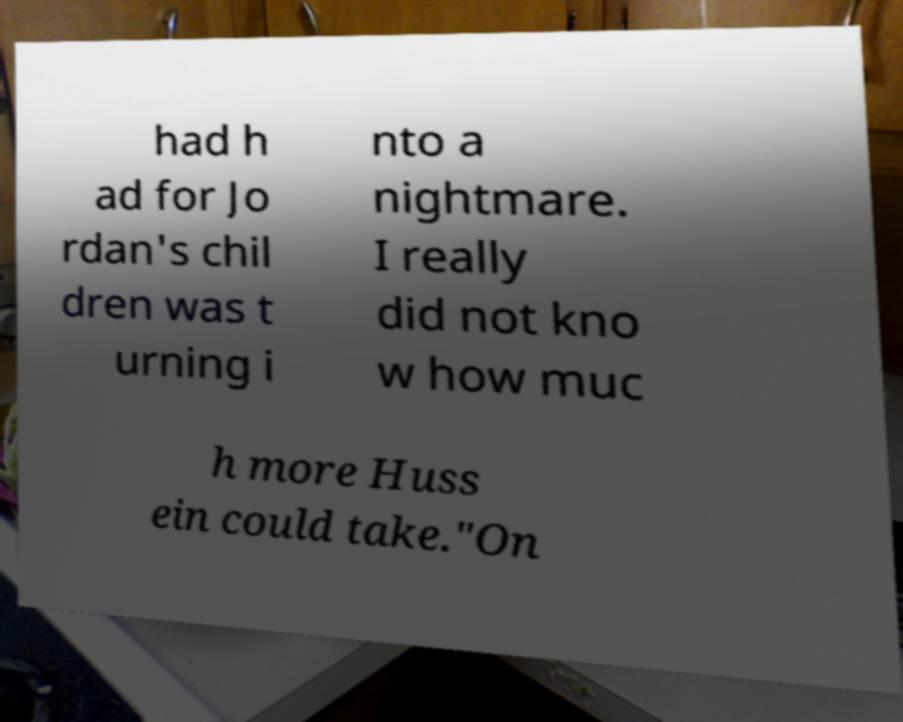Please identify and transcribe the text found in this image. had h ad for Jo rdan's chil dren was t urning i nto a nightmare. I really did not kno w how muc h more Huss ein could take."On 